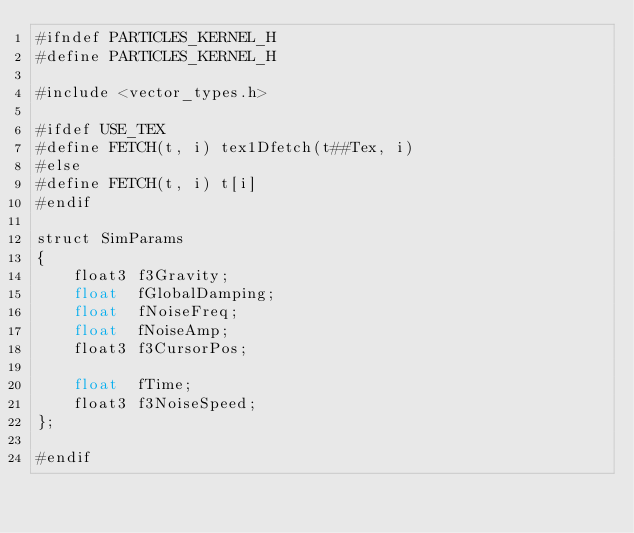Convert code to text. <code><loc_0><loc_0><loc_500><loc_500><_Cuda_>#ifndef PARTICLES_KERNEL_H
#define PARTICLES_KERNEL_H

#include <vector_types.h>

#ifdef USE_TEX
#define FETCH(t, i) tex1Dfetch(t##Tex, i)
#else
#define FETCH(t, i) t[i]
#endif

struct SimParams
{
	float3 f3Gravity;
	float  fGlobalDamping;
	float  fNoiseFreq;
	float  fNoiseAmp;
	float3 f3CursorPos;

	float  fTime;
	float3 f3NoiseSpeed;
};

#endif
</code> 